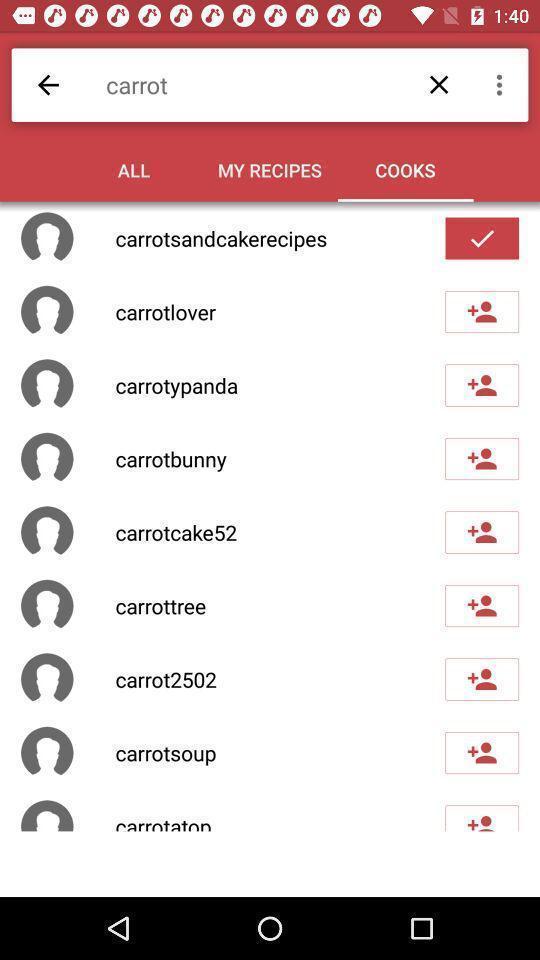What details can you identify in this image? Screen displaying the cooks page. 